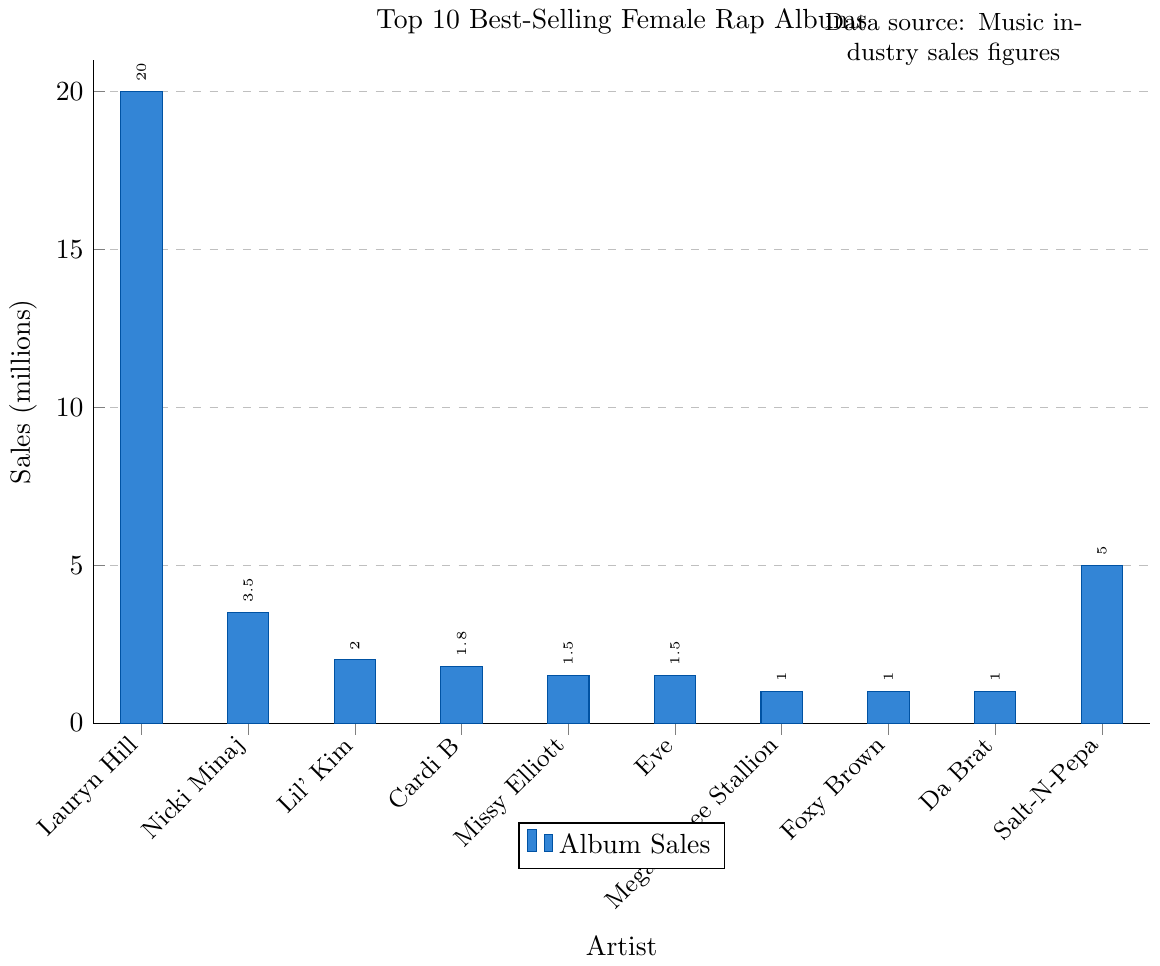What is the best-selling female rap album according to the chart? The highest bar in the chart represents the album with the greatest sales. "The Miseducation of Lauryn Hill" by Lauryn Hill stands out as having the tallest bar.
Answer: "The Miseducation of Lauryn Hill" by Lauryn Hill How many albums sold more than 5 million copies? According to the chart, only two albums have bars that are taller than the 5 million mark. Those are "The Miseducation of Lauryn Hill" by Lauryn Hill and "Very Necessary" by Salt-N-Pepa.
Answer: 2 By how many millions do the sales of "The Miseducation of Lauryn Hill" surpass the sales of "Pink Friday" by Nicki Minaj? The sales of "The Miseducation of Lauryn Hill" is 20 million and the sales of "Pink Friday" is 3.5 million. The difference is 20 - 3.5 = 16.5 million.
Answer: 16.5 million Which album has the smallest sales figure, and what is that figure? The bar representing "Cuz I Love You" by Lizzo is the shortest, signifying the smallest sales figure of 0.5 million.
Answer: "Cuz I Love You" by Lizzo, 0.5 million What is the total sales figure for all Nicki Minaj albums listed? The sales figures for Nicki Minaj albums are 3.5 (Pink Friday), 2.5 (The Pinkprint), and 1.2 (Queen). Summing these gives 3.5 + 2.5 + 1.2 = 7.2 million.
Answer: 7.2 million Which artist has the second highest-selling album, and what is the sales figure? The second highest bar corresponds to "Very Necessary" by Salt-N-Pepa with a sales figure of 5 million.
Answer: "Very Necessary" by Salt-N-Pepa, 5 million What is the average sales figure of all the albums in the chart? Summing the sales figures: 20 + 3.5 + 2 + 1.8 + 1.5 + 1.5 + 1 + 1 + 1 + 5 = 38.3 million. There are 10 albums, so the average is 38.3 / 10 = 3.83 million.
Answer: 3.83 million Compare the sales of the albums by Megan Thee Stallion and Foxy Brown. Which one has higher sales and by how much? Both Megan Thee Stallion's "Good News" and Foxy Brown's "Ill Na Na" have sales figures of 1 million. Thus, their sales are equal.
Answer: Their sales are equal Which artist appears most frequently in the chart, and how many albums do they have listed? Nicki Minaj appears three times in the chart with albums "Pink Friday," "The Pinkprint," and "Queen."
Answer: Nicki Minaj, 3 albums 